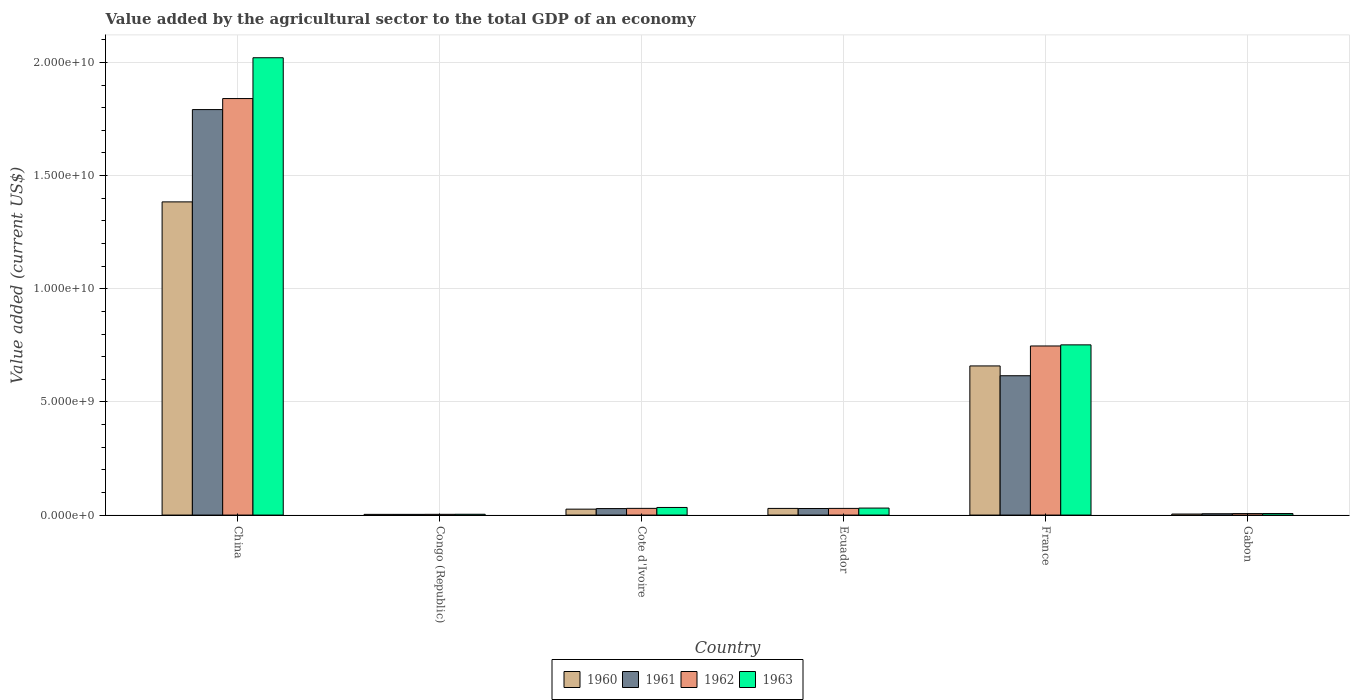How many different coloured bars are there?
Your answer should be compact. 4. How many groups of bars are there?
Your response must be concise. 6. Are the number of bars per tick equal to the number of legend labels?
Your answer should be very brief. Yes. What is the label of the 4th group of bars from the left?
Offer a terse response. Ecuador. What is the value added by the agricultural sector to the total GDP in 1960 in Cote d'Ivoire?
Provide a short and direct response. 2.62e+08. Across all countries, what is the maximum value added by the agricultural sector to the total GDP in 1960?
Provide a succinct answer. 1.38e+1. Across all countries, what is the minimum value added by the agricultural sector to the total GDP in 1963?
Offer a terse response. 3.61e+07. In which country was the value added by the agricultural sector to the total GDP in 1961 minimum?
Provide a short and direct response. Congo (Republic). What is the total value added by the agricultural sector to the total GDP in 1960 in the graph?
Your response must be concise. 2.11e+1. What is the difference between the value added by the agricultural sector to the total GDP in 1960 in France and that in Gabon?
Give a very brief answer. 6.54e+09. What is the difference between the value added by the agricultural sector to the total GDP in 1960 in France and the value added by the agricultural sector to the total GDP in 1963 in Gabon?
Your answer should be very brief. 6.52e+09. What is the average value added by the agricultural sector to the total GDP in 1960 per country?
Provide a succinct answer. 3.51e+09. What is the difference between the value added by the agricultural sector to the total GDP of/in 1963 and value added by the agricultural sector to the total GDP of/in 1960 in Ecuador?
Give a very brief answer. 1.46e+07. What is the ratio of the value added by the agricultural sector to the total GDP in 1962 in Cote d'Ivoire to that in France?
Offer a very short reply. 0.04. Is the value added by the agricultural sector to the total GDP in 1963 in Ecuador less than that in Gabon?
Your answer should be very brief. No. Is the difference between the value added by the agricultural sector to the total GDP in 1963 in China and France greater than the difference between the value added by the agricultural sector to the total GDP in 1960 in China and France?
Offer a very short reply. Yes. What is the difference between the highest and the second highest value added by the agricultural sector to the total GDP in 1960?
Make the answer very short. 1.35e+1. What is the difference between the highest and the lowest value added by the agricultural sector to the total GDP in 1960?
Ensure brevity in your answer.  1.38e+1. In how many countries, is the value added by the agricultural sector to the total GDP in 1963 greater than the average value added by the agricultural sector to the total GDP in 1963 taken over all countries?
Provide a short and direct response. 2. Is the sum of the value added by the agricultural sector to the total GDP in 1961 in Ecuador and France greater than the maximum value added by the agricultural sector to the total GDP in 1960 across all countries?
Your response must be concise. No. Is it the case that in every country, the sum of the value added by the agricultural sector to the total GDP in 1961 and value added by the agricultural sector to the total GDP in 1963 is greater than the sum of value added by the agricultural sector to the total GDP in 1960 and value added by the agricultural sector to the total GDP in 1962?
Your answer should be very brief. No. What does the 1st bar from the left in Gabon represents?
Your response must be concise. 1960. How many countries are there in the graph?
Ensure brevity in your answer.  6. Does the graph contain any zero values?
Make the answer very short. No. Where does the legend appear in the graph?
Provide a short and direct response. Bottom center. What is the title of the graph?
Provide a short and direct response. Value added by the agricultural sector to the total GDP of an economy. Does "1988" appear as one of the legend labels in the graph?
Your answer should be compact. No. What is the label or title of the X-axis?
Ensure brevity in your answer.  Country. What is the label or title of the Y-axis?
Your answer should be very brief. Value added (current US$). What is the Value added (current US$) in 1960 in China?
Make the answer very short. 1.38e+1. What is the Value added (current US$) in 1961 in China?
Provide a succinct answer. 1.79e+1. What is the Value added (current US$) in 1962 in China?
Provide a succinct answer. 1.84e+1. What is the Value added (current US$) of 1963 in China?
Ensure brevity in your answer.  2.02e+1. What is the Value added (current US$) in 1960 in Congo (Republic)?
Ensure brevity in your answer.  3.11e+07. What is the Value added (current US$) in 1961 in Congo (Republic)?
Your answer should be compact. 3.11e+07. What is the Value added (current US$) of 1962 in Congo (Republic)?
Your answer should be compact. 3.30e+07. What is the Value added (current US$) of 1963 in Congo (Republic)?
Provide a short and direct response. 3.61e+07. What is the Value added (current US$) of 1960 in Cote d'Ivoire?
Your response must be concise. 2.62e+08. What is the Value added (current US$) in 1961 in Cote d'Ivoire?
Keep it short and to the point. 2.87e+08. What is the Value added (current US$) of 1962 in Cote d'Ivoire?
Ensure brevity in your answer.  2.96e+08. What is the Value added (current US$) in 1963 in Cote d'Ivoire?
Ensure brevity in your answer.  3.36e+08. What is the Value added (current US$) of 1960 in Ecuador?
Your answer should be very brief. 2.94e+08. What is the Value added (current US$) of 1961 in Ecuador?
Your answer should be very brief. 2.91e+08. What is the Value added (current US$) in 1962 in Ecuador?
Ensure brevity in your answer.  2.95e+08. What is the Value added (current US$) in 1963 in Ecuador?
Give a very brief answer. 3.09e+08. What is the Value added (current US$) in 1960 in France?
Provide a short and direct response. 6.59e+09. What is the Value added (current US$) in 1961 in France?
Your answer should be compact. 6.16e+09. What is the Value added (current US$) in 1962 in France?
Provide a succinct answer. 7.47e+09. What is the Value added (current US$) in 1963 in France?
Offer a terse response. 7.52e+09. What is the Value added (current US$) in 1960 in Gabon?
Give a very brief answer. 4.55e+07. What is the Value added (current US$) of 1961 in Gabon?
Provide a short and direct response. 5.90e+07. What is the Value added (current US$) in 1962 in Gabon?
Provide a succinct answer. 6.56e+07. What is the Value added (current US$) of 1963 in Gabon?
Provide a succinct answer. 6.81e+07. Across all countries, what is the maximum Value added (current US$) in 1960?
Keep it short and to the point. 1.38e+1. Across all countries, what is the maximum Value added (current US$) of 1961?
Offer a terse response. 1.79e+1. Across all countries, what is the maximum Value added (current US$) in 1962?
Keep it short and to the point. 1.84e+1. Across all countries, what is the maximum Value added (current US$) of 1963?
Ensure brevity in your answer.  2.02e+1. Across all countries, what is the minimum Value added (current US$) in 1960?
Keep it short and to the point. 3.11e+07. Across all countries, what is the minimum Value added (current US$) of 1961?
Provide a short and direct response. 3.11e+07. Across all countries, what is the minimum Value added (current US$) in 1962?
Your answer should be very brief. 3.30e+07. Across all countries, what is the minimum Value added (current US$) in 1963?
Keep it short and to the point. 3.61e+07. What is the total Value added (current US$) in 1960 in the graph?
Your response must be concise. 2.11e+1. What is the total Value added (current US$) in 1961 in the graph?
Make the answer very short. 2.47e+1. What is the total Value added (current US$) of 1962 in the graph?
Ensure brevity in your answer.  2.66e+1. What is the total Value added (current US$) of 1963 in the graph?
Make the answer very short. 2.85e+1. What is the difference between the Value added (current US$) of 1960 in China and that in Congo (Republic)?
Your answer should be very brief. 1.38e+1. What is the difference between the Value added (current US$) in 1961 in China and that in Congo (Republic)?
Provide a succinct answer. 1.79e+1. What is the difference between the Value added (current US$) of 1962 in China and that in Congo (Republic)?
Your answer should be compact. 1.84e+1. What is the difference between the Value added (current US$) in 1963 in China and that in Congo (Republic)?
Your answer should be very brief. 2.02e+1. What is the difference between the Value added (current US$) of 1960 in China and that in Cote d'Ivoire?
Your response must be concise. 1.36e+1. What is the difference between the Value added (current US$) of 1961 in China and that in Cote d'Ivoire?
Give a very brief answer. 1.76e+1. What is the difference between the Value added (current US$) in 1962 in China and that in Cote d'Ivoire?
Ensure brevity in your answer.  1.81e+1. What is the difference between the Value added (current US$) in 1963 in China and that in Cote d'Ivoire?
Make the answer very short. 1.99e+1. What is the difference between the Value added (current US$) in 1960 in China and that in Ecuador?
Offer a very short reply. 1.35e+1. What is the difference between the Value added (current US$) in 1961 in China and that in Ecuador?
Offer a very short reply. 1.76e+1. What is the difference between the Value added (current US$) in 1962 in China and that in Ecuador?
Keep it short and to the point. 1.81e+1. What is the difference between the Value added (current US$) of 1963 in China and that in Ecuador?
Keep it short and to the point. 1.99e+1. What is the difference between the Value added (current US$) in 1960 in China and that in France?
Your response must be concise. 7.25e+09. What is the difference between the Value added (current US$) in 1961 in China and that in France?
Keep it short and to the point. 1.18e+1. What is the difference between the Value added (current US$) in 1962 in China and that in France?
Offer a very short reply. 1.09e+1. What is the difference between the Value added (current US$) in 1963 in China and that in France?
Give a very brief answer. 1.27e+1. What is the difference between the Value added (current US$) in 1960 in China and that in Gabon?
Provide a succinct answer. 1.38e+1. What is the difference between the Value added (current US$) of 1961 in China and that in Gabon?
Your answer should be very brief. 1.79e+1. What is the difference between the Value added (current US$) in 1962 in China and that in Gabon?
Provide a succinct answer. 1.83e+1. What is the difference between the Value added (current US$) in 1963 in China and that in Gabon?
Offer a terse response. 2.01e+1. What is the difference between the Value added (current US$) in 1960 in Congo (Republic) and that in Cote d'Ivoire?
Provide a short and direct response. -2.31e+08. What is the difference between the Value added (current US$) of 1961 in Congo (Republic) and that in Cote d'Ivoire?
Provide a short and direct response. -2.56e+08. What is the difference between the Value added (current US$) in 1962 in Congo (Republic) and that in Cote d'Ivoire?
Give a very brief answer. -2.63e+08. What is the difference between the Value added (current US$) of 1963 in Congo (Republic) and that in Cote d'Ivoire?
Offer a terse response. -3.00e+08. What is the difference between the Value added (current US$) in 1960 in Congo (Republic) and that in Ecuador?
Offer a very short reply. -2.63e+08. What is the difference between the Value added (current US$) of 1961 in Congo (Republic) and that in Ecuador?
Keep it short and to the point. -2.59e+08. What is the difference between the Value added (current US$) in 1962 in Congo (Republic) and that in Ecuador?
Offer a terse response. -2.62e+08. What is the difference between the Value added (current US$) in 1963 in Congo (Republic) and that in Ecuador?
Give a very brief answer. -2.73e+08. What is the difference between the Value added (current US$) of 1960 in Congo (Republic) and that in France?
Your response must be concise. -6.56e+09. What is the difference between the Value added (current US$) of 1961 in Congo (Republic) and that in France?
Make the answer very short. -6.13e+09. What is the difference between the Value added (current US$) in 1962 in Congo (Republic) and that in France?
Offer a very short reply. -7.44e+09. What is the difference between the Value added (current US$) of 1963 in Congo (Republic) and that in France?
Offer a very short reply. -7.49e+09. What is the difference between the Value added (current US$) in 1960 in Congo (Republic) and that in Gabon?
Offer a very short reply. -1.44e+07. What is the difference between the Value added (current US$) of 1961 in Congo (Republic) and that in Gabon?
Your answer should be compact. -2.79e+07. What is the difference between the Value added (current US$) of 1962 in Congo (Republic) and that in Gabon?
Provide a succinct answer. -3.26e+07. What is the difference between the Value added (current US$) in 1963 in Congo (Republic) and that in Gabon?
Ensure brevity in your answer.  -3.20e+07. What is the difference between the Value added (current US$) of 1960 in Cote d'Ivoire and that in Ecuador?
Offer a terse response. -3.28e+07. What is the difference between the Value added (current US$) of 1961 in Cote d'Ivoire and that in Ecuador?
Provide a succinct answer. -3.61e+06. What is the difference between the Value added (current US$) of 1962 in Cote d'Ivoire and that in Ecuador?
Offer a very short reply. 1.03e+06. What is the difference between the Value added (current US$) in 1963 in Cote d'Ivoire and that in Ecuador?
Ensure brevity in your answer.  2.70e+07. What is the difference between the Value added (current US$) of 1960 in Cote d'Ivoire and that in France?
Provide a succinct answer. -6.33e+09. What is the difference between the Value added (current US$) in 1961 in Cote d'Ivoire and that in France?
Offer a very short reply. -5.87e+09. What is the difference between the Value added (current US$) in 1962 in Cote d'Ivoire and that in France?
Your answer should be compact. -7.18e+09. What is the difference between the Value added (current US$) in 1963 in Cote d'Ivoire and that in France?
Provide a short and direct response. -7.19e+09. What is the difference between the Value added (current US$) in 1960 in Cote d'Ivoire and that in Gabon?
Your response must be concise. 2.16e+08. What is the difference between the Value added (current US$) of 1961 in Cote d'Ivoire and that in Gabon?
Ensure brevity in your answer.  2.28e+08. What is the difference between the Value added (current US$) in 1962 in Cote d'Ivoire and that in Gabon?
Keep it short and to the point. 2.31e+08. What is the difference between the Value added (current US$) of 1963 in Cote d'Ivoire and that in Gabon?
Provide a succinct answer. 2.68e+08. What is the difference between the Value added (current US$) in 1960 in Ecuador and that in France?
Keep it short and to the point. -6.30e+09. What is the difference between the Value added (current US$) of 1961 in Ecuador and that in France?
Give a very brief answer. -5.87e+09. What is the difference between the Value added (current US$) of 1962 in Ecuador and that in France?
Make the answer very short. -7.18e+09. What is the difference between the Value added (current US$) of 1963 in Ecuador and that in France?
Offer a terse response. -7.21e+09. What is the difference between the Value added (current US$) of 1960 in Ecuador and that in Gabon?
Provide a succinct answer. 2.49e+08. What is the difference between the Value added (current US$) in 1961 in Ecuador and that in Gabon?
Provide a succinct answer. 2.31e+08. What is the difference between the Value added (current US$) in 1962 in Ecuador and that in Gabon?
Give a very brief answer. 2.30e+08. What is the difference between the Value added (current US$) of 1963 in Ecuador and that in Gabon?
Your answer should be compact. 2.41e+08. What is the difference between the Value added (current US$) in 1960 in France and that in Gabon?
Provide a short and direct response. 6.54e+09. What is the difference between the Value added (current US$) of 1961 in France and that in Gabon?
Your response must be concise. 6.10e+09. What is the difference between the Value added (current US$) in 1962 in France and that in Gabon?
Provide a short and direct response. 7.41e+09. What is the difference between the Value added (current US$) in 1963 in France and that in Gabon?
Offer a terse response. 7.45e+09. What is the difference between the Value added (current US$) in 1960 in China and the Value added (current US$) in 1961 in Congo (Republic)?
Your answer should be compact. 1.38e+1. What is the difference between the Value added (current US$) in 1960 in China and the Value added (current US$) in 1962 in Congo (Republic)?
Offer a terse response. 1.38e+1. What is the difference between the Value added (current US$) of 1960 in China and the Value added (current US$) of 1963 in Congo (Republic)?
Your answer should be very brief. 1.38e+1. What is the difference between the Value added (current US$) in 1961 in China and the Value added (current US$) in 1962 in Congo (Republic)?
Your answer should be compact. 1.79e+1. What is the difference between the Value added (current US$) of 1961 in China and the Value added (current US$) of 1963 in Congo (Republic)?
Give a very brief answer. 1.79e+1. What is the difference between the Value added (current US$) in 1962 in China and the Value added (current US$) in 1963 in Congo (Republic)?
Offer a terse response. 1.84e+1. What is the difference between the Value added (current US$) in 1960 in China and the Value added (current US$) in 1961 in Cote d'Ivoire?
Your response must be concise. 1.36e+1. What is the difference between the Value added (current US$) in 1960 in China and the Value added (current US$) in 1962 in Cote d'Ivoire?
Ensure brevity in your answer.  1.35e+1. What is the difference between the Value added (current US$) in 1960 in China and the Value added (current US$) in 1963 in Cote d'Ivoire?
Ensure brevity in your answer.  1.35e+1. What is the difference between the Value added (current US$) in 1961 in China and the Value added (current US$) in 1962 in Cote d'Ivoire?
Make the answer very short. 1.76e+1. What is the difference between the Value added (current US$) in 1961 in China and the Value added (current US$) in 1963 in Cote d'Ivoire?
Your answer should be compact. 1.76e+1. What is the difference between the Value added (current US$) in 1962 in China and the Value added (current US$) in 1963 in Cote d'Ivoire?
Ensure brevity in your answer.  1.81e+1. What is the difference between the Value added (current US$) in 1960 in China and the Value added (current US$) in 1961 in Ecuador?
Provide a short and direct response. 1.35e+1. What is the difference between the Value added (current US$) of 1960 in China and the Value added (current US$) of 1962 in Ecuador?
Your answer should be compact. 1.35e+1. What is the difference between the Value added (current US$) in 1960 in China and the Value added (current US$) in 1963 in Ecuador?
Give a very brief answer. 1.35e+1. What is the difference between the Value added (current US$) of 1961 in China and the Value added (current US$) of 1962 in Ecuador?
Your answer should be compact. 1.76e+1. What is the difference between the Value added (current US$) in 1961 in China and the Value added (current US$) in 1963 in Ecuador?
Keep it short and to the point. 1.76e+1. What is the difference between the Value added (current US$) in 1962 in China and the Value added (current US$) in 1963 in Ecuador?
Your answer should be very brief. 1.81e+1. What is the difference between the Value added (current US$) in 1960 in China and the Value added (current US$) in 1961 in France?
Offer a very short reply. 7.68e+09. What is the difference between the Value added (current US$) of 1960 in China and the Value added (current US$) of 1962 in France?
Ensure brevity in your answer.  6.37e+09. What is the difference between the Value added (current US$) in 1960 in China and the Value added (current US$) in 1963 in France?
Ensure brevity in your answer.  6.32e+09. What is the difference between the Value added (current US$) of 1961 in China and the Value added (current US$) of 1962 in France?
Your answer should be very brief. 1.04e+1. What is the difference between the Value added (current US$) of 1961 in China and the Value added (current US$) of 1963 in France?
Provide a short and direct response. 1.04e+1. What is the difference between the Value added (current US$) in 1962 in China and the Value added (current US$) in 1963 in France?
Ensure brevity in your answer.  1.09e+1. What is the difference between the Value added (current US$) in 1960 in China and the Value added (current US$) in 1961 in Gabon?
Your answer should be very brief. 1.38e+1. What is the difference between the Value added (current US$) in 1960 in China and the Value added (current US$) in 1962 in Gabon?
Make the answer very short. 1.38e+1. What is the difference between the Value added (current US$) in 1960 in China and the Value added (current US$) in 1963 in Gabon?
Your answer should be compact. 1.38e+1. What is the difference between the Value added (current US$) in 1961 in China and the Value added (current US$) in 1962 in Gabon?
Your answer should be compact. 1.79e+1. What is the difference between the Value added (current US$) of 1961 in China and the Value added (current US$) of 1963 in Gabon?
Your answer should be compact. 1.78e+1. What is the difference between the Value added (current US$) in 1962 in China and the Value added (current US$) in 1963 in Gabon?
Ensure brevity in your answer.  1.83e+1. What is the difference between the Value added (current US$) in 1960 in Congo (Republic) and the Value added (current US$) in 1961 in Cote d'Ivoire?
Offer a very short reply. -2.56e+08. What is the difference between the Value added (current US$) of 1960 in Congo (Republic) and the Value added (current US$) of 1962 in Cote d'Ivoire?
Your answer should be very brief. -2.65e+08. What is the difference between the Value added (current US$) of 1960 in Congo (Republic) and the Value added (current US$) of 1963 in Cote d'Ivoire?
Provide a succinct answer. -3.05e+08. What is the difference between the Value added (current US$) in 1961 in Congo (Republic) and the Value added (current US$) in 1962 in Cote d'Ivoire?
Ensure brevity in your answer.  -2.65e+08. What is the difference between the Value added (current US$) of 1961 in Congo (Republic) and the Value added (current US$) of 1963 in Cote d'Ivoire?
Make the answer very short. -3.05e+08. What is the difference between the Value added (current US$) in 1962 in Congo (Republic) and the Value added (current US$) in 1963 in Cote d'Ivoire?
Offer a terse response. -3.03e+08. What is the difference between the Value added (current US$) of 1960 in Congo (Republic) and the Value added (current US$) of 1961 in Ecuador?
Your answer should be compact. -2.59e+08. What is the difference between the Value added (current US$) in 1960 in Congo (Republic) and the Value added (current US$) in 1962 in Ecuador?
Your answer should be very brief. -2.64e+08. What is the difference between the Value added (current US$) of 1960 in Congo (Republic) and the Value added (current US$) of 1963 in Ecuador?
Your response must be concise. -2.78e+08. What is the difference between the Value added (current US$) in 1961 in Congo (Republic) and the Value added (current US$) in 1962 in Ecuador?
Provide a short and direct response. -2.64e+08. What is the difference between the Value added (current US$) in 1961 in Congo (Republic) and the Value added (current US$) in 1963 in Ecuador?
Offer a terse response. -2.78e+08. What is the difference between the Value added (current US$) in 1962 in Congo (Republic) and the Value added (current US$) in 1963 in Ecuador?
Provide a succinct answer. -2.76e+08. What is the difference between the Value added (current US$) of 1960 in Congo (Republic) and the Value added (current US$) of 1961 in France?
Offer a terse response. -6.13e+09. What is the difference between the Value added (current US$) in 1960 in Congo (Republic) and the Value added (current US$) in 1962 in France?
Your answer should be compact. -7.44e+09. What is the difference between the Value added (current US$) in 1960 in Congo (Republic) and the Value added (current US$) in 1963 in France?
Offer a terse response. -7.49e+09. What is the difference between the Value added (current US$) in 1961 in Congo (Republic) and the Value added (current US$) in 1962 in France?
Provide a short and direct response. -7.44e+09. What is the difference between the Value added (current US$) of 1961 in Congo (Republic) and the Value added (current US$) of 1963 in France?
Offer a terse response. -7.49e+09. What is the difference between the Value added (current US$) in 1962 in Congo (Republic) and the Value added (current US$) in 1963 in France?
Provide a succinct answer. -7.49e+09. What is the difference between the Value added (current US$) in 1960 in Congo (Republic) and the Value added (current US$) in 1961 in Gabon?
Offer a very short reply. -2.79e+07. What is the difference between the Value added (current US$) of 1960 in Congo (Republic) and the Value added (current US$) of 1962 in Gabon?
Give a very brief answer. -3.45e+07. What is the difference between the Value added (current US$) in 1960 in Congo (Republic) and the Value added (current US$) in 1963 in Gabon?
Your response must be concise. -3.70e+07. What is the difference between the Value added (current US$) of 1961 in Congo (Republic) and the Value added (current US$) of 1962 in Gabon?
Your answer should be compact. -3.45e+07. What is the difference between the Value added (current US$) in 1961 in Congo (Republic) and the Value added (current US$) in 1963 in Gabon?
Your response must be concise. -3.70e+07. What is the difference between the Value added (current US$) in 1962 in Congo (Republic) and the Value added (current US$) in 1963 in Gabon?
Your response must be concise. -3.51e+07. What is the difference between the Value added (current US$) in 1960 in Cote d'Ivoire and the Value added (current US$) in 1961 in Ecuador?
Your answer should be very brief. -2.88e+07. What is the difference between the Value added (current US$) in 1960 in Cote d'Ivoire and the Value added (current US$) in 1962 in Ecuador?
Make the answer very short. -3.35e+07. What is the difference between the Value added (current US$) of 1960 in Cote d'Ivoire and the Value added (current US$) of 1963 in Ecuador?
Offer a terse response. -4.74e+07. What is the difference between the Value added (current US$) of 1961 in Cote d'Ivoire and the Value added (current US$) of 1962 in Ecuador?
Offer a very short reply. -8.28e+06. What is the difference between the Value added (current US$) of 1961 in Cote d'Ivoire and the Value added (current US$) of 1963 in Ecuador?
Your answer should be compact. -2.22e+07. What is the difference between the Value added (current US$) of 1962 in Cote d'Ivoire and the Value added (current US$) of 1963 in Ecuador?
Provide a short and direct response. -1.29e+07. What is the difference between the Value added (current US$) of 1960 in Cote d'Ivoire and the Value added (current US$) of 1961 in France?
Offer a very short reply. -5.90e+09. What is the difference between the Value added (current US$) of 1960 in Cote d'Ivoire and the Value added (current US$) of 1962 in France?
Keep it short and to the point. -7.21e+09. What is the difference between the Value added (current US$) in 1960 in Cote d'Ivoire and the Value added (current US$) in 1963 in France?
Ensure brevity in your answer.  -7.26e+09. What is the difference between the Value added (current US$) of 1961 in Cote d'Ivoire and the Value added (current US$) of 1962 in France?
Make the answer very short. -7.19e+09. What is the difference between the Value added (current US$) in 1961 in Cote d'Ivoire and the Value added (current US$) in 1963 in France?
Your answer should be very brief. -7.23e+09. What is the difference between the Value added (current US$) in 1962 in Cote d'Ivoire and the Value added (current US$) in 1963 in France?
Your answer should be compact. -7.23e+09. What is the difference between the Value added (current US$) of 1960 in Cote d'Ivoire and the Value added (current US$) of 1961 in Gabon?
Ensure brevity in your answer.  2.03e+08. What is the difference between the Value added (current US$) of 1960 in Cote d'Ivoire and the Value added (current US$) of 1962 in Gabon?
Your response must be concise. 1.96e+08. What is the difference between the Value added (current US$) in 1960 in Cote d'Ivoire and the Value added (current US$) in 1963 in Gabon?
Your answer should be very brief. 1.94e+08. What is the difference between the Value added (current US$) of 1961 in Cote d'Ivoire and the Value added (current US$) of 1962 in Gabon?
Your response must be concise. 2.21e+08. What is the difference between the Value added (current US$) of 1961 in Cote d'Ivoire and the Value added (current US$) of 1963 in Gabon?
Provide a short and direct response. 2.19e+08. What is the difference between the Value added (current US$) in 1962 in Cote d'Ivoire and the Value added (current US$) in 1963 in Gabon?
Provide a succinct answer. 2.28e+08. What is the difference between the Value added (current US$) of 1960 in Ecuador and the Value added (current US$) of 1961 in France?
Offer a terse response. -5.86e+09. What is the difference between the Value added (current US$) in 1960 in Ecuador and the Value added (current US$) in 1962 in France?
Offer a terse response. -7.18e+09. What is the difference between the Value added (current US$) of 1960 in Ecuador and the Value added (current US$) of 1963 in France?
Make the answer very short. -7.23e+09. What is the difference between the Value added (current US$) of 1961 in Ecuador and the Value added (current US$) of 1962 in France?
Your answer should be compact. -7.18e+09. What is the difference between the Value added (current US$) of 1961 in Ecuador and the Value added (current US$) of 1963 in France?
Offer a terse response. -7.23e+09. What is the difference between the Value added (current US$) in 1962 in Ecuador and the Value added (current US$) in 1963 in France?
Give a very brief answer. -7.23e+09. What is the difference between the Value added (current US$) in 1960 in Ecuador and the Value added (current US$) in 1961 in Gabon?
Offer a very short reply. 2.35e+08. What is the difference between the Value added (current US$) in 1960 in Ecuador and the Value added (current US$) in 1962 in Gabon?
Make the answer very short. 2.29e+08. What is the difference between the Value added (current US$) of 1960 in Ecuador and the Value added (current US$) of 1963 in Gabon?
Keep it short and to the point. 2.26e+08. What is the difference between the Value added (current US$) in 1961 in Ecuador and the Value added (current US$) in 1962 in Gabon?
Make the answer very short. 2.25e+08. What is the difference between the Value added (current US$) in 1961 in Ecuador and the Value added (current US$) in 1963 in Gabon?
Provide a succinct answer. 2.22e+08. What is the difference between the Value added (current US$) in 1962 in Ecuador and the Value added (current US$) in 1963 in Gabon?
Make the answer very short. 2.27e+08. What is the difference between the Value added (current US$) in 1960 in France and the Value added (current US$) in 1961 in Gabon?
Offer a terse response. 6.53e+09. What is the difference between the Value added (current US$) in 1960 in France and the Value added (current US$) in 1962 in Gabon?
Offer a terse response. 6.52e+09. What is the difference between the Value added (current US$) in 1960 in France and the Value added (current US$) in 1963 in Gabon?
Your answer should be compact. 6.52e+09. What is the difference between the Value added (current US$) in 1961 in France and the Value added (current US$) in 1962 in Gabon?
Provide a succinct answer. 6.09e+09. What is the difference between the Value added (current US$) of 1961 in France and the Value added (current US$) of 1963 in Gabon?
Your answer should be compact. 6.09e+09. What is the difference between the Value added (current US$) of 1962 in France and the Value added (current US$) of 1963 in Gabon?
Your answer should be very brief. 7.40e+09. What is the average Value added (current US$) of 1960 per country?
Provide a succinct answer. 3.51e+09. What is the average Value added (current US$) of 1961 per country?
Keep it short and to the point. 4.12e+09. What is the average Value added (current US$) in 1962 per country?
Your response must be concise. 4.43e+09. What is the average Value added (current US$) in 1963 per country?
Give a very brief answer. 4.75e+09. What is the difference between the Value added (current US$) of 1960 and Value added (current US$) of 1961 in China?
Make the answer very short. -4.08e+09. What is the difference between the Value added (current US$) in 1960 and Value added (current US$) in 1962 in China?
Make the answer very short. -4.57e+09. What is the difference between the Value added (current US$) of 1960 and Value added (current US$) of 1963 in China?
Your answer should be very brief. -6.37e+09. What is the difference between the Value added (current US$) of 1961 and Value added (current US$) of 1962 in China?
Your response must be concise. -4.87e+08. What is the difference between the Value added (current US$) in 1961 and Value added (current US$) in 1963 in China?
Your answer should be very brief. -2.29e+09. What is the difference between the Value added (current US$) in 1962 and Value added (current US$) in 1963 in China?
Keep it short and to the point. -1.80e+09. What is the difference between the Value added (current US$) of 1960 and Value added (current US$) of 1961 in Congo (Republic)?
Provide a succinct answer. 8239.47. What is the difference between the Value added (current US$) in 1960 and Value added (current US$) in 1962 in Congo (Republic)?
Provide a succinct answer. -1.89e+06. What is the difference between the Value added (current US$) of 1960 and Value added (current US$) of 1963 in Congo (Republic)?
Provide a short and direct response. -5.00e+06. What is the difference between the Value added (current US$) of 1961 and Value added (current US$) of 1962 in Congo (Republic)?
Give a very brief answer. -1.90e+06. What is the difference between the Value added (current US$) of 1961 and Value added (current US$) of 1963 in Congo (Republic)?
Offer a terse response. -5.01e+06. What is the difference between the Value added (current US$) of 1962 and Value added (current US$) of 1963 in Congo (Republic)?
Offer a very short reply. -3.11e+06. What is the difference between the Value added (current US$) in 1960 and Value added (current US$) in 1961 in Cote d'Ivoire?
Give a very brief answer. -2.52e+07. What is the difference between the Value added (current US$) of 1960 and Value added (current US$) of 1962 in Cote d'Ivoire?
Give a very brief answer. -3.45e+07. What is the difference between the Value added (current US$) in 1960 and Value added (current US$) in 1963 in Cote d'Ivoire?
Your answer should be compact. -7.45e+07. What is the difference between the Value added (current US$) in 1961 and Value added (current US$) in 1962 in Cote d'Ivoire?
Ensure brevity in your answer.  -9.30e+06. What is the difference between the Value added (current US$) of 1961 and Value added (current US$) of 1963 in Cote d'Ivoire?
Provide a short and direct response. -4.92e+07. What is the difference between the Value added (current US$) in 1962 and Value added (current US$) in 1963 in Cote d'Ivoire?
Offer a very short reply. -3.99e+07. What is the difference between the Value added (current US$) of 1960 and Value added (current US$) of 1961 in Ecuador?
Keep it short and to the point. 3.96e+06. What is the difference between the Value added (current US$) in 1960 and Value added (current US$) in 1962 in Ecuador?
Your answer should be compact. -6.97e+05. What is the difference between the Value added (current US$) in 1960 and Value added (current US$) in 1963 in Ecuador?
Your response must be concise. -1.46e+07. What is the difference between the Value added (current US$) of 1961 and Value added (current US$) of 1962 in Ecuador?
Your answer should be compact. -4.66e+06. What is the difference between the Value added (current US$) of 1961 and Value added (current US$) of 1963 in Ecuador?
Ensure brevity in your answer.  -1.86e+07. What is the difference between the Value added (current US$) in 1962 and Value added (current US$) in 1963 in Ecuador?
Your answer should be compact. -1.39e+07. What is the difference between the Value added (current US$) in 1960 and Value added (current US$) in 1961 in France?
Your answer should be compact. 4.33e+08. What is the difference between the Value added (current US$) in 1960 and Value added (current US$) in 1962 in France?
Keep it short and to the point. -8.82e+08. What is the difference between the Value added (current US$) in 1960 and Value added (current US$) in 1963 in France?
Your answer should be very brief. -9.31e+08. What is the difference between the Value added (current US$) of 1961 and Value added (current US$) of 1962 in France?
Your answer should be very brief. -1.32e+09. What is the difference between the Value added (current US$) of 1961 and Value added (current US$) of 1963 in France?
Keep it short and to the point. -1.36e+09. What is the difference between the Value added (current US$) of 1962 and Value added (current US$) of 1963 in France?
Ensure brevity in your answer.  -4.92e+07. What is the difference between the Value added (current US$) in 1960 and Value added (current US$) in 1961 in Gabon?
Provide a succinct answer. -1.35e+07. What is the difference between the Value added (current US$) in 1960 and Value added (current US$) in 1962 in Gabon?
Provide a succinct answer. -2.01e+07. What is the difference between the Value added (current US$) of 1960 and Value added (current US$) of 1963 in Gabon?
Your response must be concise. -2.26e+07. What is the difference between the Value added (current US$) of 1961 and Value added (current US$) of 1962 in Gabon?
Provide a succinct answer. -6.57e+06. What is the difference between the Value added (current US$) in 1961 and Value added (current US$) in 1963 in Gabon?
Your response must be concise. -9.07e+06. What is the difference between the Value added (current US$) in 1962 and Value added (current US$) in 1963 in Gabon?
Your answer should be very brief. -2.50e+06. What is the ratio of the Value added (current US$) of 1960 in China to that in Congo (Republic)?
Your response must be concise. 445.15. What is the ratio of the Value added (current US$) of 1961 in China to that in Congo (Republic)?
Give a very brief answer. 576.48. What is the ratio of the Value added (current US$) in 1962 in China to that in Congo (Republic)?
Provide a short and direct response. 558.09. What is the ratio of the Value added (current US$) of 1963 in China to that in Congo (Republic)?
Offer a terse response. 559.95. What is the ratio of the Value added (current US$) in 1960 in China to that in Cote d'Ivoire?
Offer a terse response. 52.89. What is the ratio of the Value added (current US$) in 1961 in China to that in Cote d'Ivoire?
Provide a succinct answer. 62.45. What is the ratio of the Value added (current US$) in 1962 in China to that in Cote d'Ivoire?
Ensure brevity in your answer.  62.14. What is the ratio of the Value added (current US$) of 1963 in China to that in Cote d'Ivoire?
Your answer should be very brief. 60.12. What is the ratio of the Value added (current US$) in 1960 in China to that in Ecuador?
Provide a short and direct response. 47. What is the ratio of the Value added (current US$) in 1961 in China to that in Ecuador?
Provide a succinct answer. 61.67. What is the ratio of the Value added (current US$) in 1962 in China to that in Ecuador?
Give a very brief answer. 62.35. What is the ratio of the Value added (current US$) of 1963 in China to that in Ecuador?
Your answer should be compact. 65.37. What is the ratio of the Value added (current US$) of 1960 in China to that in France?
Keep it short and to the point. 2.1. What is the ratio of the Value added (current US$) in 1961 in China to that in France?
Give a very brief answer. 2.91. What is the ratio of the Value added (current US$) in 1962 in China to that in France?
Offer a very short reply. 2.46. What is the ratio of the Value added (current US$) of 1963 in China to that in France?
Your response must be concise. 2.69. What is the ratio of the Value added (current US$) in 1960 in China to that in Gabon?
Your response must be concise. 303.94. What is the ratio of the Value added (current US$) of 1961 in China to that in Gabon?
Your answer should be compact. 303.54. What is the ratio of the Value added (current US$) of 1962 in China to that in Gabon?
Your answer should be compact. 280.58. What is the ratio of the Value added (current US$) in 1963 in China to that in Gabon?
Make the answer very short. 296.75. What is the ratio of the Value added (current US$) of 1960 in Congo (Republic) to that in Cote d'Ivoire?
Your response must be concise. 0.12. What is the ratio of the Value added (current US$) of 1961 in Congo (Republic) to that in Cote d'Ivoire?
Keep it short and to the point. 0.11. What is the ratio of the Value added (current US$) of 1962 in Congo (Republic) to that in Cote d'Ivoire?
Your response must be concise. 0.11. What is the ratio of the Value added (current US$) in 1963 in Congo (Republic) to that in Cote d'Ivoire?
Make the answer very short. 0.11. What is the ratio of the Value added (current US$) in 1960 in Congo (Republic) to that in Ecuador?
Your answer should be compact. 0.11. What is the ratio of the Value added (current US$) in 1961 in Congo (Republic) to that in Ecuador?
Ensure brevity in your answer.  0.11. What is the ratio of the Value added (current US$) of 1962 in Congo (Republic) to that in Ecuador?
Ensure brevity in your answer.  0.11. What is the ratio of the Value added (current US$) in 1963 in Congo (Republic) to that in Ecuador?
Your answer should be compact. 0.12. What is the ratio of the Value added (current US$) of 1960 in Congo (Republic) to that in France?
Offer a terse response. 0. What is the ratio of the Value added (current US$) of 1961 in Congo (Republic) to that in France?
Provide a short and direct response. 0.01. What is the ratio of the Value added (current US$) in 1962 in Congo (Republic) to that in France?
Your answer should be very brief. 0. What is the ratio of the Value added (current US$) in 1963 in Congo (Republic) to that in France?
Your response must be concise. 0. What is the ratio of the Value added (current US$) in 1960 in Congo (Republic) to that in Gabon?
Keep it short and to the point. 0.68. What is the ratio of the Value added (current US$) of 1961 in Congo (Republic) to that in Gabon?
Offer a very short reply. 0.53. What is the ratio of the Value added (current US$) in 1962 in Congo (Republic) to that in Gabon?
Give a very brief answer. 0.5. What is the ratio of the Value added (current US$) of 1963 in Congo (Republic) to that in Gabon?
Give a very brief answer. 0.53. What is the ratio of the Value added (current US$) in 1960 in Cote d'Ivoire to that in Ecuador?
Keep it short and to the point. 0.89. What is the ratio of the Value added (current US$) of 1961 in Cote d'Ivoire to that in Ecuador?
Your answer should be compact. 0.99. What is the ratio of the Value added (current US$) of 1962 in Cote d'Ivoire to that in Ecuador?
Your answer should be very brief. 1. What is the ratio of the Value added (current US$) of 1963 in Cote d'Ivoire to that in Ecuador?
Keep it short and to the point. 1.09. What is the ratio of the Value added (current US$) of 1960 in Cote d'Ivoire to that in France?
Keep it short and to the point. 0.04. What is the ratio of the Value added (current US$) of 1961 in Cote d'Ivoire to that in France?
Ensure brevity in your answer.  0.05. What is the ratio of the Value added (current US$) of 1962 in Cote d'Ivoire to that in France?
Your answer should be very brief. 0.04. What is the ratio of the Value added (current US$) of 1963 in Cote d'Ivoire to that in France?
Your answer should be very brief. 0.04. What is the ratio of the Value added (current US$) in 1960 in Cote d'Ivoire to that in Gabon?
Make the answer very short. 5.75. What is the ratio of the Value added (current US$) in 1961 in Cote d'Ivoire to that in Gabon?
Keep it short and to the point. 4.86. What is the ratio of the Value added (current US$) of 1962 in Cote d'Ivoire to that in Gabon?
Your answer should be compact. 4.52. What is the ratio of the Value added (current US$) of 1963 in Cote d'Ivoire to that in Gabon?
Your answer should be compact. 4.94. What is the ratio of the Value added (current US$) of 1960 in Ecuador to that in France?
Ensure brevity in your answer.  0.04. What is the ratio of the Value added (current US$) of 1961 in Ecuador to that in France?
Keep it short and to the point. 0.05. What is the ratio of the Value added (current US$) of 1962 in Ecuador to that in France?
Give a very brief answer. 0.04. What is the ratio of the Value added (current US$) in 1963 in Ecuador to that in France?
Your answer should be compact. 0.04. What is the ratio of the Value added (current US$) in 1960 in Ecuador to that in Gabon?
Make the answer very short. 6.47. What is the ratio of the Value added (current US$) in 1961 in Ecuador to that in Gabon?
Ensure brevity in your answer.  4.92. What is the ratio of the Value added (current US$) of 1962 in Ecuador to that in Gabon?
Give a very brief answer. 4.5. What is the ratio of the Value added (current US$) in 1963 in Ecuador to that in Gabon?
Provide a short and direct response. 4.54. What is the ratio of the Value added (current US$) in 1960 in France to that in Gabon?
Keep it short and to the point. 144.73. What is the ratio of the Value added (current US$) in 1961 in France to that in Gabon?
Your answer should be compact. 104.3. What is the ratio of the Value added (current US$) in 1962 in France to that in Gabon?
Offer a terse response. 113.91. What is the ratio of the Value added (current US$) of 1963 in France to that in Gabon?
Make the answer very short. 110.45. What is the difference between the highest and the second highest Value added (current US$) in 1960?
Provide a succinct answer. 7.25e+09. What is the difference between the highest and the second highest Value added (current US$) in 1961?
Provide a short and direct response. 1.18e+1. What is the difference between the highest and the second highest Value added (current US$) in 1962?
Make the answer very short. 1.09e+1. What is the difference between the highest and the second highest Value added (current US$) in 1963?
Keep it short and to the point. 1.27e+1. What is the difference between the highest and the lowest Value added (current US$) of 1960?
Offer a terse response. 1.38e+1. What is the difference between the highest and the lowest Value added (current US$) in 1961?
Your answer should be very brief. 1.79e+1. What is the difference between the highest and the lowest Value added (current US$) of 1962?
Your answer should be very brief. 1.84e+1. What is the difference between the highest and the lowest Value added (current US$) of 1963?
Your response must be concise. 2.02e+1. 